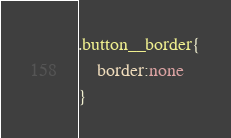<code> <loc_0><loc_0><loc_500><loc_500><_CSS_>.button__border{
    border:none
}</code> 